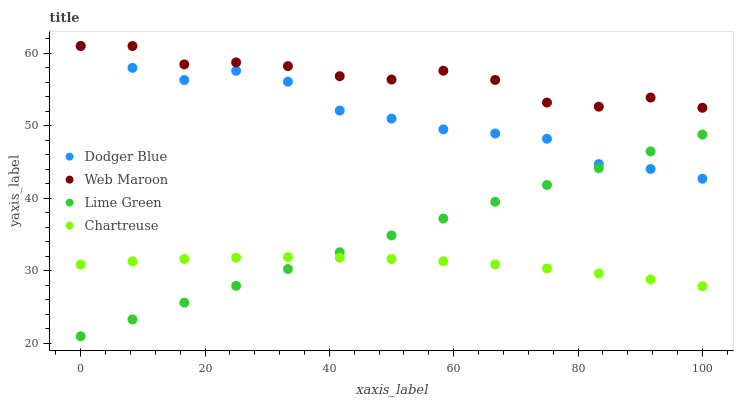Does Chartreuse have the minimum area under the curve?
Answer yes or no. Yes. Does Web Maroon have the maximum area under the curve?
Answer yes or no. Yes. Does Dodger Blue have the minimum area under the curve?
Answer yes or no. No. Does Dodger Blue have the maximum area under the curve?
Answer yes or no. No. Is Lime Green the smoothest?
Answer yes or no. Yes. Is Web Maroon the roughest?
Answer yes or no. Yes. Is Chartreuse the smoothest?
Answer yes or no. No. Is Chartreuse the roughest?
Answer yes or no. No. Does Lime Green have the lowest value?
Answer yes or no. Yes. Does Chartreuse have the lowest value?
Answer yes or no. No. Does Dodger Blue have the highest value?
Answer yes or no. Yes. Does Chartreuse have the highest value?
Answer yes or no. No. Is Chartreuse less than Web Maroon?
Answer yes or no. Yes. Is Dodger Blue greater than Chartreuse?
Answer yes or no. Yes. Does Web Maroon intersect Dodger Blue?
Answer yes or no. Yes. Is Web Maroon less than Dodger Blue?
Answer yes or no. No. Is Web Maroon greater than Dodger Blue?
Answer yes or no. No. Does Chartreuse intersect Web Maroon?
Answer yes or no. No. 